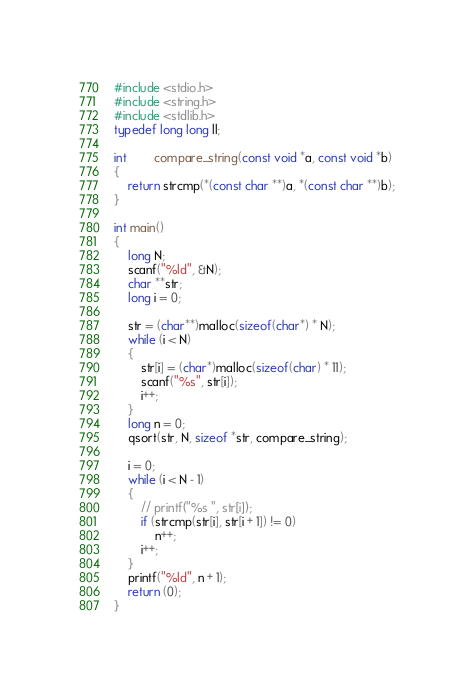<code> <loc_0><loc_0><loc_500><loc_500><_C_>#include <stdio.h>
#include <string.h>
#include <stdlib.h>
typedef long long ll;

int		compare_string(const void *a, const void *b)
{
	return strcmp(*(const char **)a, *(const char **)b);
}

int main()
{
	long N;
	scanf("%ld", &N);
	char **str;
	long i = 0;

	str = (char**)malloc(sizeof(char*) * N);
	while (i < N)
	{
		str[i] = (char*)malloc(sizeof(char) * 11);
		scanf("%s", str[i]);
		i++;
	}
	long n = 0;
	qsort(str, N, sizeof *str, compare_string);

	i = 0;
	while (i < N - 1)
	{
		// printf("%s ", str[i]);
		if (strcmp(str[i], str[i + 1]) != 0)
			n++;
		i++;
	}
	printf("%ld", n + 1);
	return (0);
}

</code> 